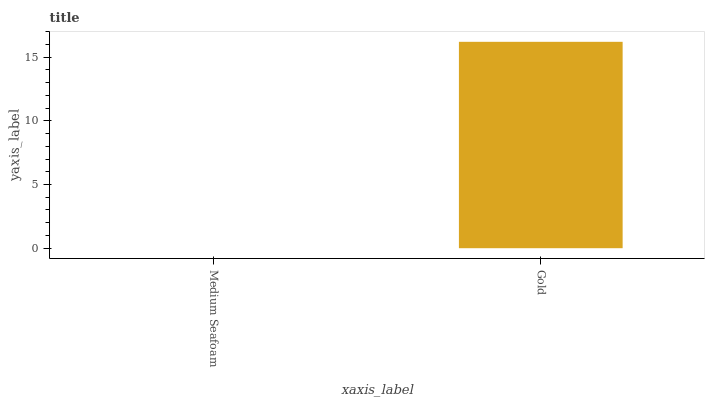Is Gold the minimum?
Answer yes or no. No. Is Gold greater than Medium Seafoam?
Answer yes or no. Yes. Is Medium Seafoam less than Gold?
Answer yes or no. Yes. Is Medium Seafoam greater than Gold?
Answer yes or no. No. Is Gold less than Medium Seafoam?
Answer yes or no. No. Is Gold the high median?
Answer yes or no. Yes. Is Medium Seafoam the low median?
Answer yes or no. Yes. Is Medium Seafoam the high median?
Answer yes or no. No. Is Gold the low median?
Answer yes or no. No. 